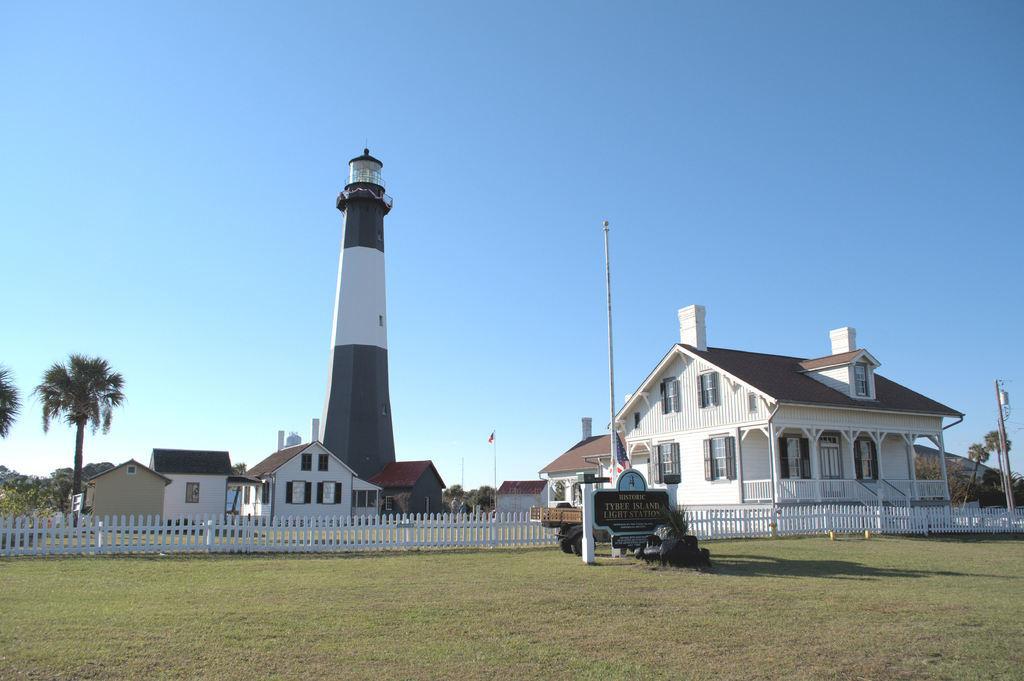How would you summarize this image in a sentence or two? In this image I can see the ground, a pole and a black colored board, a vehicle and the white colored fencing. In the background I can see few buildings, few trees, a tower, a flag and the sky. 